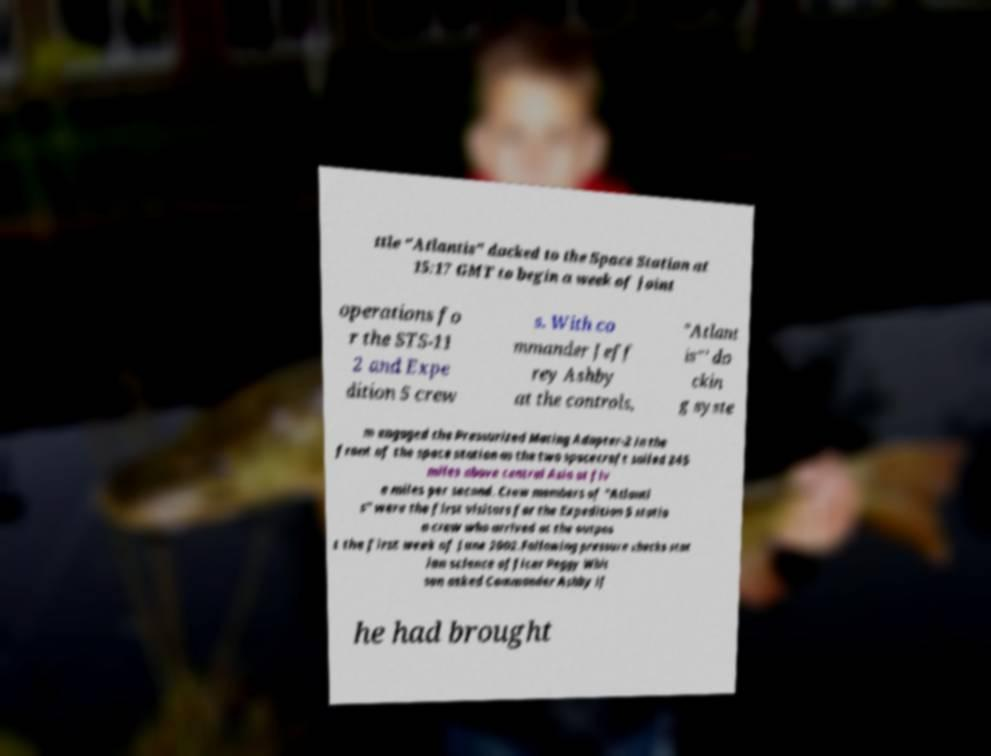Can you read and provide the text displayed in the image?This photo seems to have some interesting text. Can you extract and type it out for me? ttle "Atlantis" docked to the Space Station at 15:17 GMT to begin a week of joint operations fo r the STS-11 2 and Expe dition 5 crew s. With co mmander Jeff rey Ashby at the controls, "Atlant is"' do ckin g syste m engaged the Pressurized Mating Adapter-2 in the front of the space station as the two spacecraft sailed 245 miles above central Asia at fiv e miles per second. Crew members of "Atlanti s" were the first visitors for the Expedition 5 statio n crew who arrived at the outpos t the first week of June 2002.Following pressure checks stat ion science officer Peggy Whit son asked Commander Ashby if he had brought 